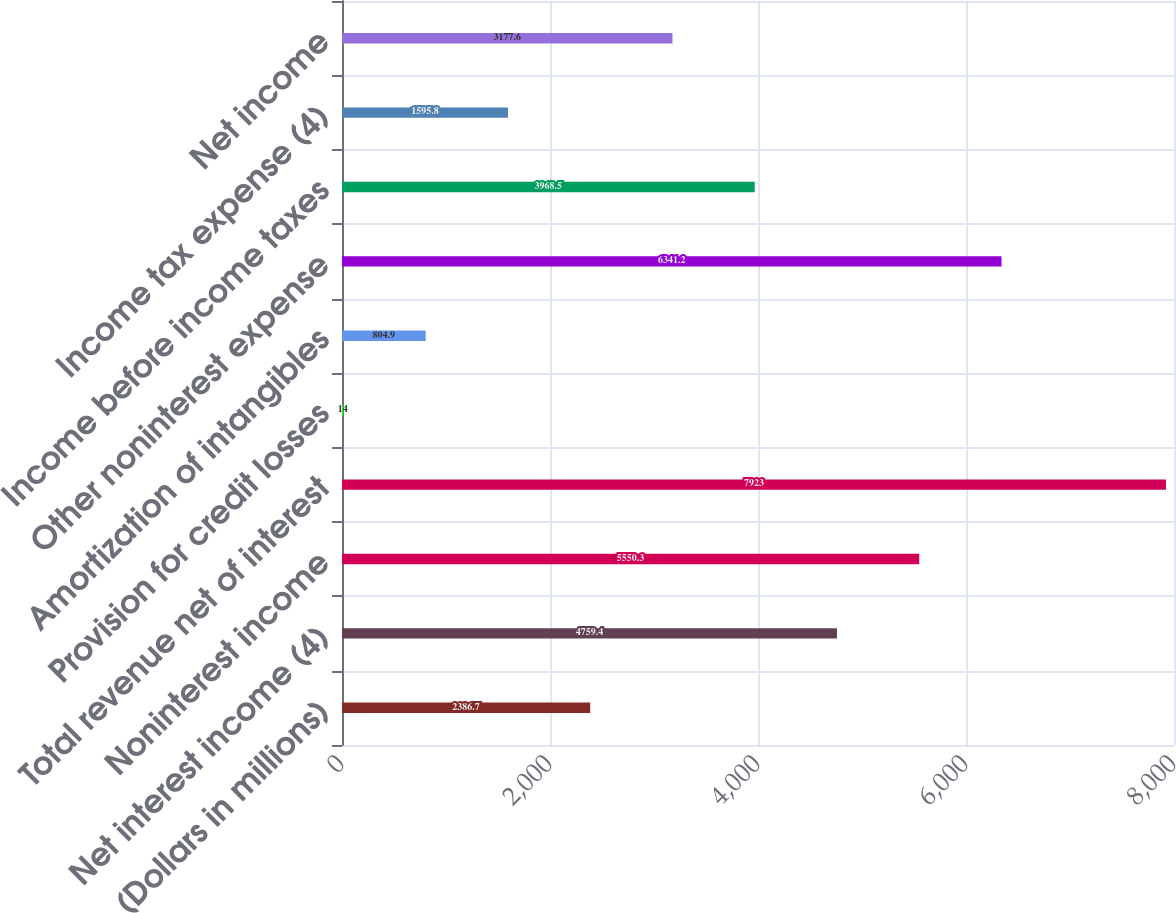Convert chart to OTSL. <chart><loc_0><loc_0><loc_500><loc_500><bar_chart><fcel>(Dollars in millions)<fcel>Net interest income (4)<fcel>Noninterest income<fcel>Total revenue net of interest<fcel>Provision for credit losses<fcel>Amortization of intangibles<fcel>Other noninterest expense<fcel>Income before income taxes<fcel>Income tax expense (4)<fcel>Net income<nl><fcel>2386.7<fcel>4759.4<fcel>5550.3<fcel>7923<fcel>14<fcel>804.9<fcel>6341.2<fcel>3968.5<fcel>1595.8<fcel>3177.6<nl></chart> 